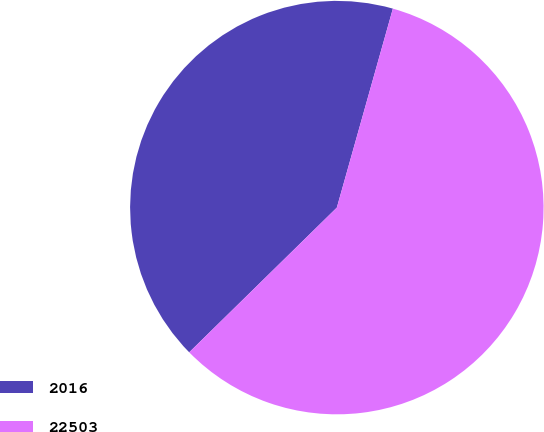<chart> <loc_0><loc_0><loc_500><loc_500><pie_chart><fcel>2016<fcel>22503<nl><fcel>41.71%<fcel>58.29%<nl></chart> 